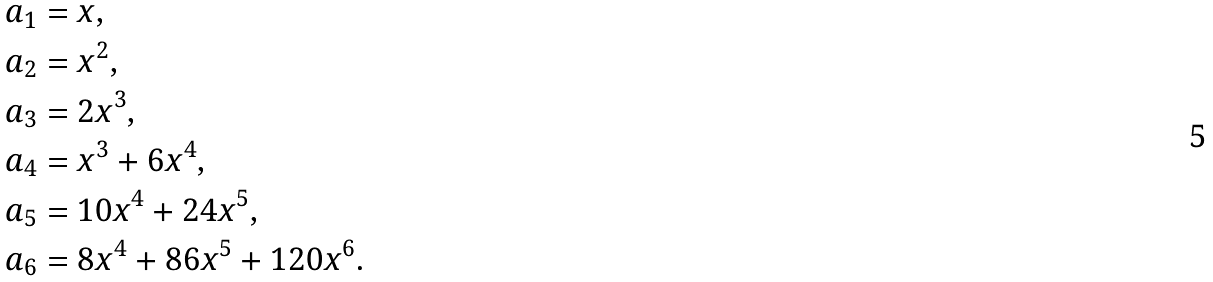<formula> <loc_0><loc_0><loc_500><loc_500>a _ { 1 } & = x , \\ a _ { 2 } & = x ^ { 2 } , \\ a _ { 3 } & = 2 x ^ { 3 } , \\ a _ { 4 } & = x ^ { 3 } + 6 x ^ { 4 } , \\ a _ { 5 } & = 1 0 x ^ { 4 } + 2 4 x ^ { 5 } , \\ a _ { 6 } & = 8 x ^ { 4 } + 8 6 x ^ { 5 } + 1 2 0 x ^ { 6 } .</formula> 